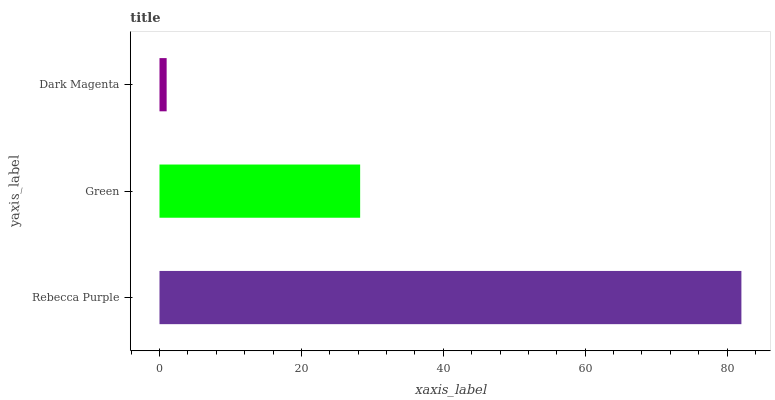Is Dark Magenta the minimum?
Answer yes or no. Yes. Is Rebecca Purple the maximum?
Answer yes or no. Yes. Is Green the minimum?
Answer yes or no. No. Is Green the maximum?
Answer yes or no. No. Is Rebecca Purple greater than Green?
Answer yes or no. Yes. Is Green less than Rebecca Purple?
Answer yes or no. Yes. Is Green greater than Rebecca Purple?
Answer yes or no. No. Is Rebecca Purple less than Green?
Answer yes or no. No. Is Green the high median?
Answer yes or no. Yes. Is Green the low median?
Answer yes or no. Yes. Is Rebecca Purple the high median?
Answer yes or no. No. Is Rebecca Purple the low median?
Answer yes or no. No. 